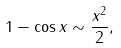Convert formula to latex. <formula><loc_0><loc_0><loc_500><loc_500>1 - \cos x \sim { \frac { x ^ { 2 } } { 2 } } ,</formula> 